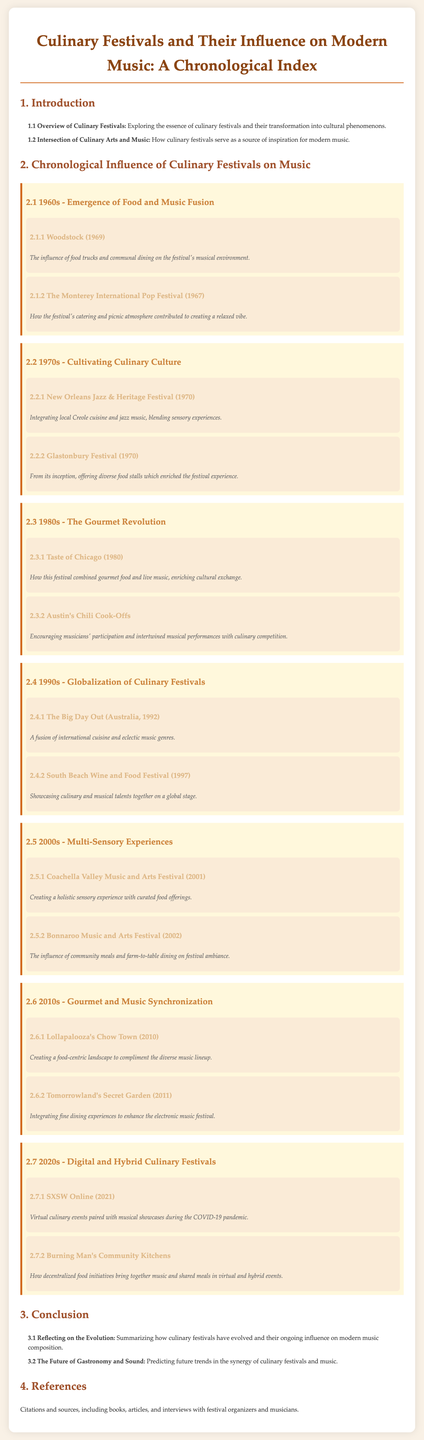what is the title of the document? The title, as mentioned in the header, reflects the content focus on culinary festivals and their impact on modern music.
Answer: Culinary Festivals and Their Influence on Modern Music: A Chronological Index what year did the Woodstock festival take place? The document specifies that the Woodstock festival occurred in 1969.
Answer: 1969 which festival is associated with local Creole cuisine? The document indicates that the New Orleans Jazz & Heritage Festival integrates local Creole cuisine and jazz music.
Answer: New Orleans Jazz & Heritage Festival how many festivals are listed from the 1990s? The document outlines two specific festivals in the 1990s.
Answer: 2 what was the year of the first Coachella Valley Music and Arts Festival? The document notes that this festival took place in 2001.
Answer: 2001 which decade highlights the concept of digital and hybrid culinary festivals? The document suggests that the 2020s discussed advancements in digital and hybrid culinary festivals.
Answer: 2020s what is a noted influence on Bonnaroo Music and Arts Festival? The document mentions the influence of community meals and farm-to-table dining on the festival ambiance.
Answer: community meals and farm-to-table dining what does "Chow Town" refer to in the context of music festivals? The document specifies that "Chow Town" at Lollapalooza is a food-centric space to complement the music lineup.
Answer: food-centric landscape which festival occurred in 2011? The document indicates that Tomorrowland's Secret Garden took place in that year.
Answer: Tomorrowland's Secret Garden 